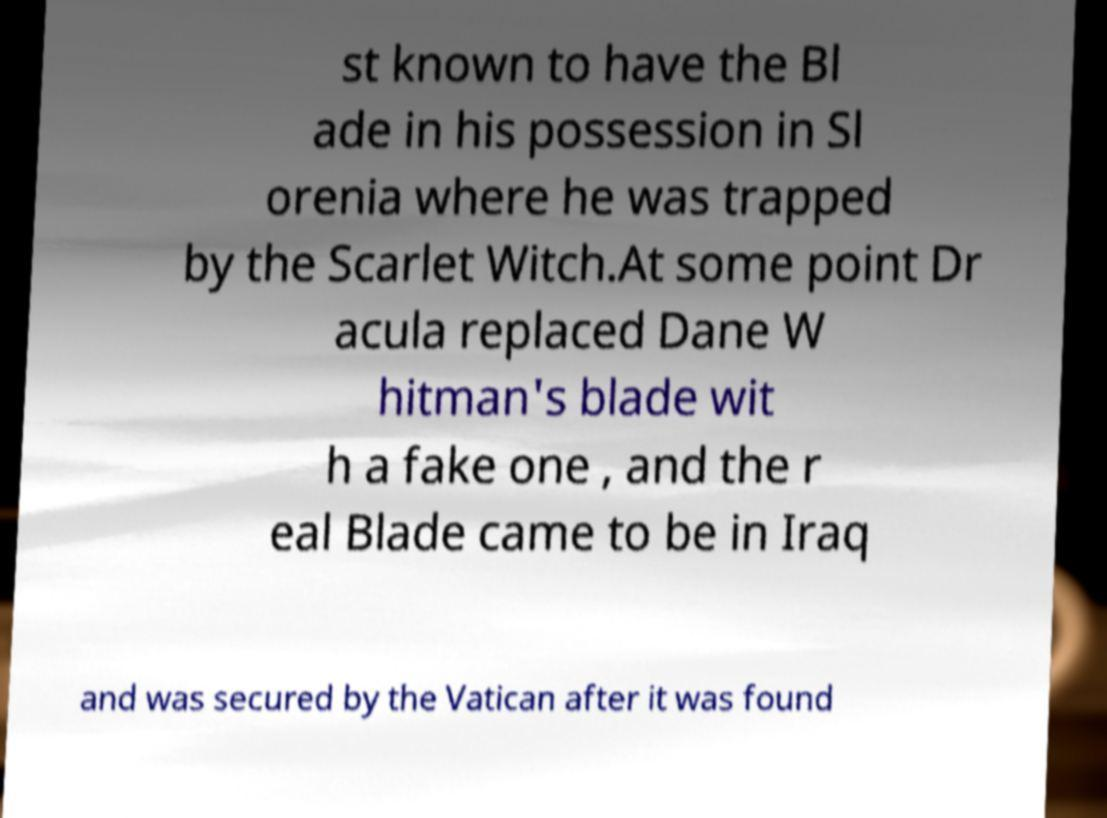Can you accurately transcribe the text from the provided image for me? st known to have the Bl ade in his possession in Sl orenia where he was trapped by the Scarlet Witch.At some point Dr acula replaced Dane W hitman's blade wit h a fake one , and the r eal Blade came to be in Iraq and was secured by the Vatican after it was found 